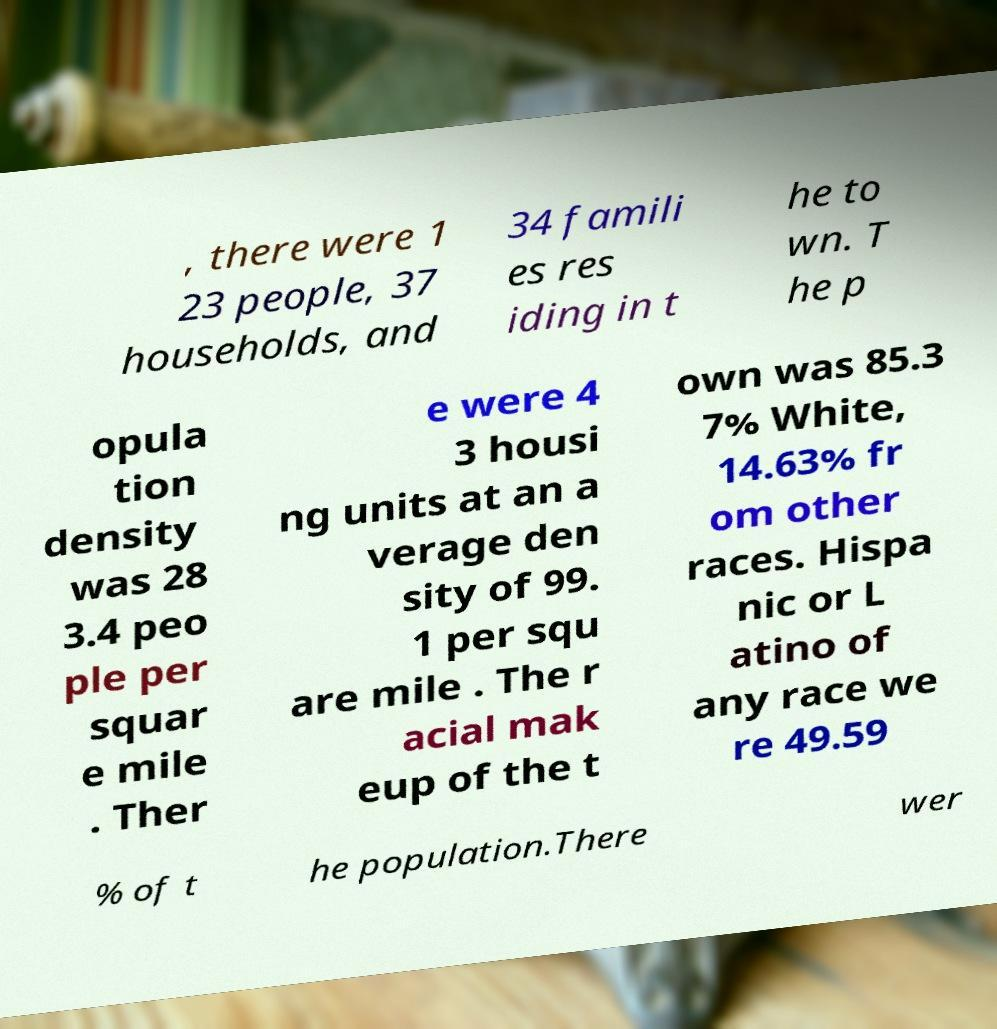For documentation purposes, I need the text within this image transcribed. Could you provide that? , there were 1 23 people, 37 households, and 34 famili es res iding in t he to wn. T he p opula tion density was 28 3.4 peo ple per squar e mile . Ther e were 4 3 housi ng units at an a verage den sity of 99. 1 per squ are mile . The r acial mak eup of the t own was 85.3 7% White, 14.63% fr om other races. Hispa nic or L atino of any race we re 49.59 % of t he population.There wer 